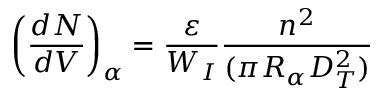<formula> <loc_0><loc_0><loc_500><loc_500>\left ( \frac { d N } { d V } \right ) _ { \alpha } = \frac { \varepsilon } { W _ { I } } \frac { n ^ { 2 } } { ( \pi R _ { \alpha } D _ { T } ^ { 2 } ) }</formula> 